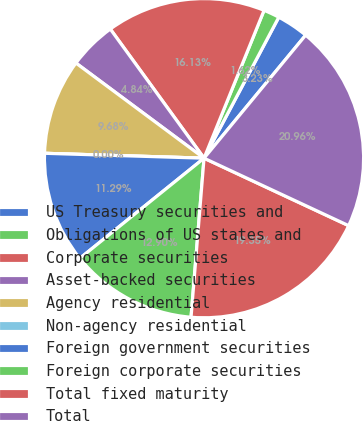Convert chart. <chart><loc_0><loc_0><loc_500><loc_500><pie_chart><fcel>US Treasury securities and<fcel>Obligations of US states and<fcel>Corporate securities<fcel>Asset-backed securities<fcel>Agency residential<fcel>Non-agency residential<fcel>Foreign government securities<fcel>Foreign corporate securities<fcel>Total fixed maturity<fcel>Total<nl><fcel>3.23%<fcel>1.62%<fcel>16.13%<fcel>4.84%<fcel>9.68%<fcel>0.0%<fcel>11.29%<fcel>12.9%<fcel>19.35%<fcel>20.96%<nl></chart> 